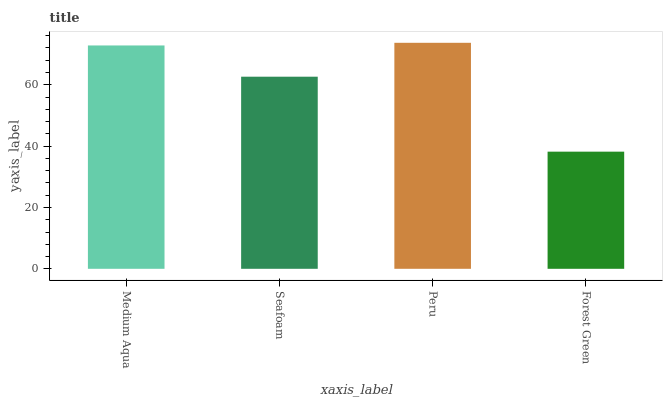Is Forest Green the minimum?
Answer yes or no. Yes. Is Peru the maximum?
Answer yes or no. Yes. Is Seafoam the minimum?
Answer yes or no. No. Is Seafoam the maximum?
Answer yes or no. No. Is Medium Aqua greater than Seafoam?
Answer yes or no. Yes. Is Seafoam less than Medium Aqua?
Answer yes or no. Yes. Is Seafoam greater than Medium Aqua?
Answer yes or no. No. Is Medium Aqua less than Seafoam?
Answer yes or no. No. Is Medium Aqua the high median?
Answer yes or no. Yes. Is Seafoam the low median?
Answer yes or no. Yes. Is Peru the high median?
Answer yes or no. No. Is Peru the low median?
Answer yes or no. No. 